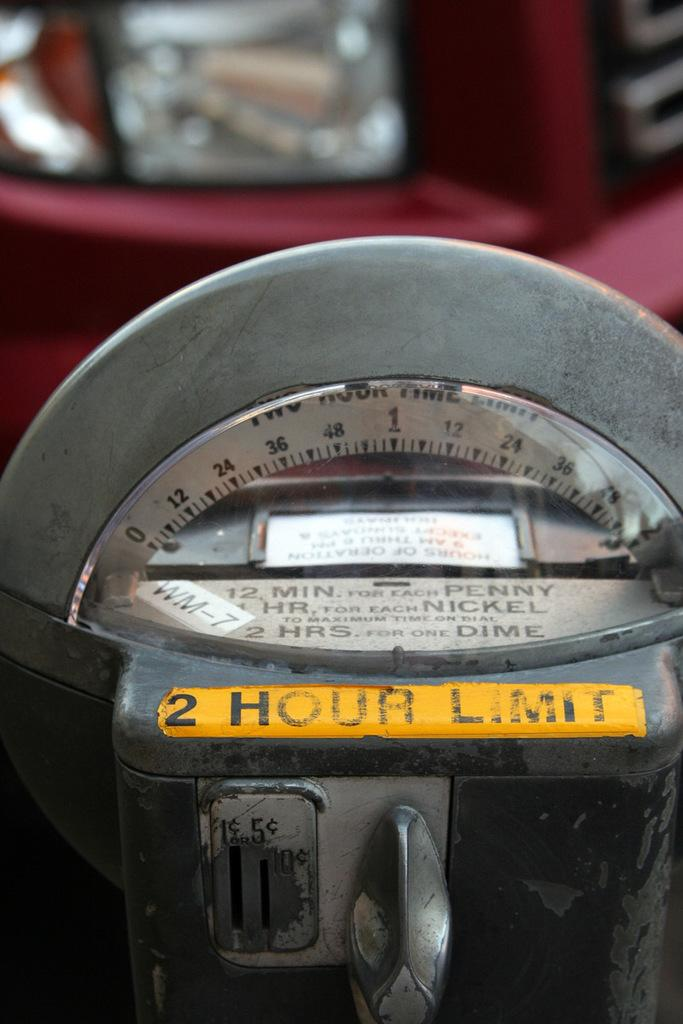<image>
Describe the image concisely. A grey parking meter states that there is a 2 hour limit. 